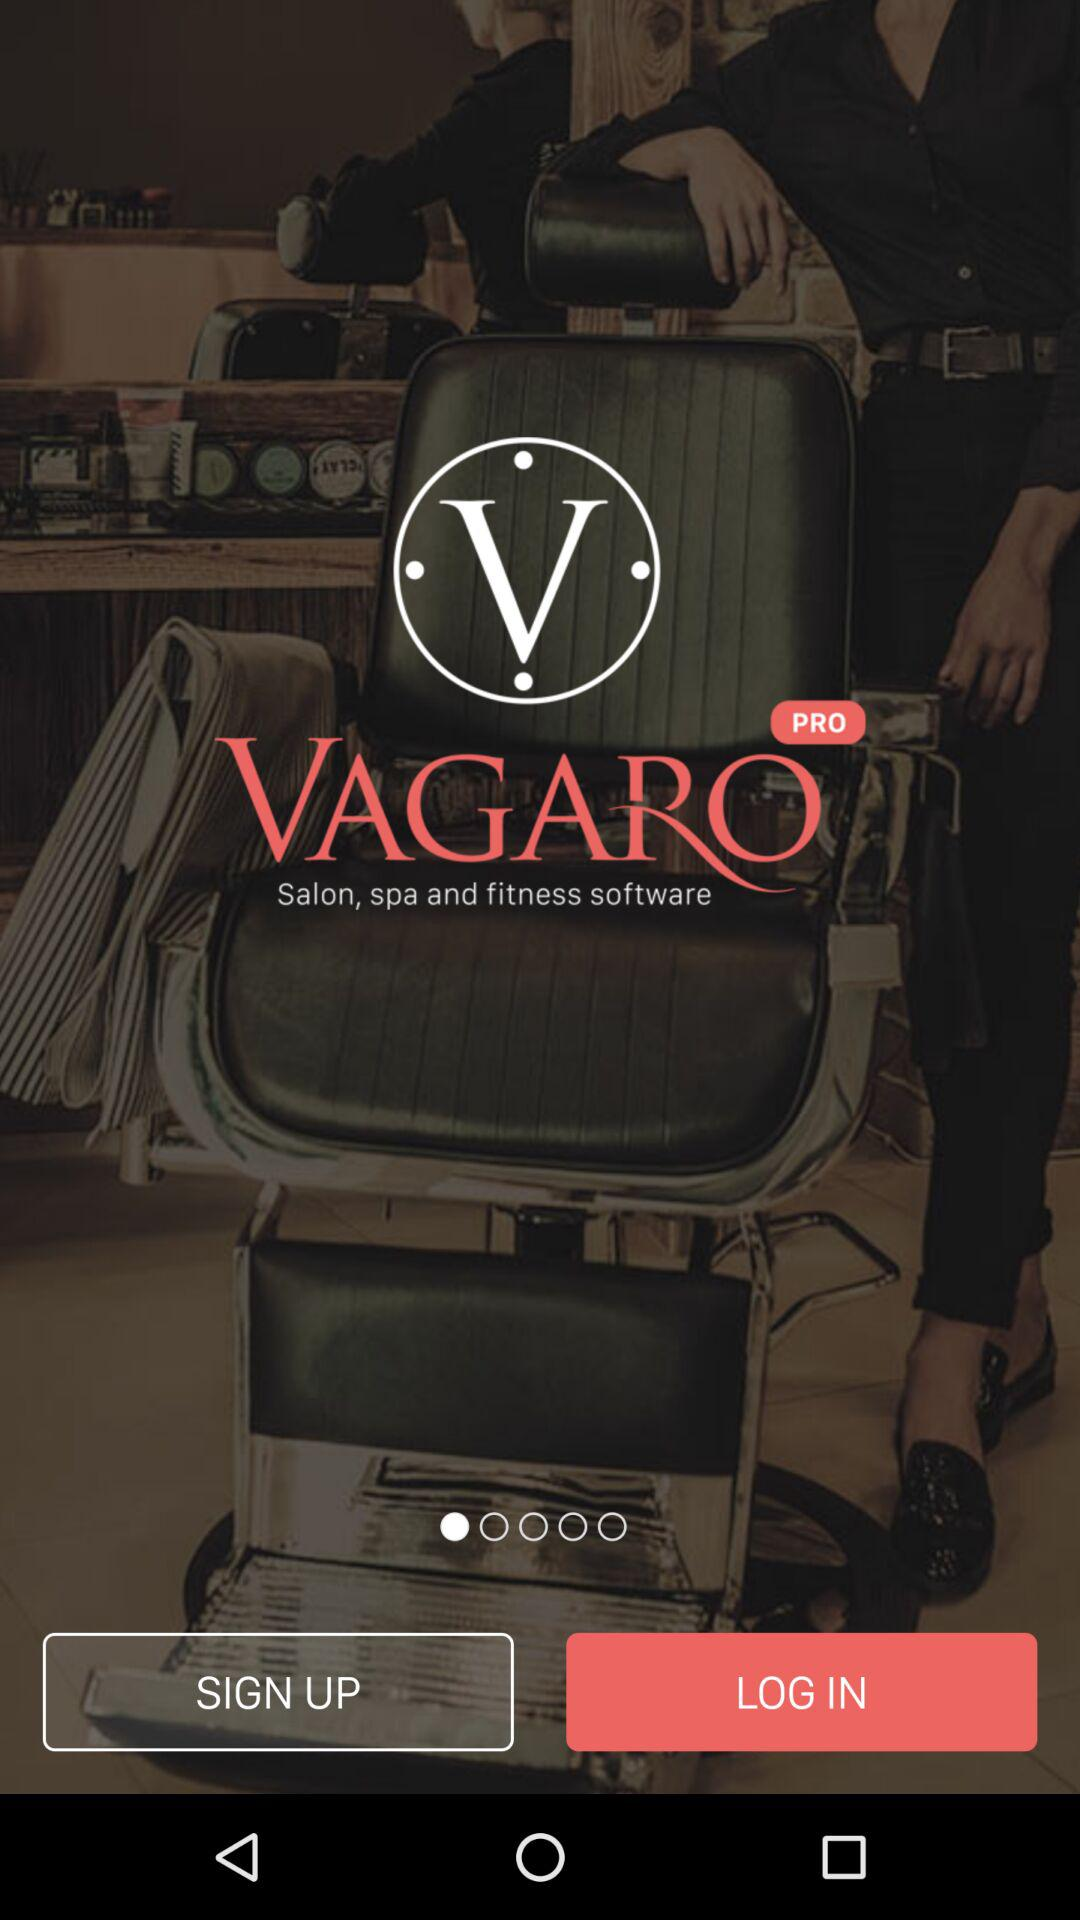What is the name of application? The name of the application is "VAGARO". 